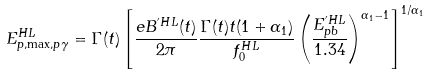Convert formula to latex. <formula><loc_0><loc_0><loc_500><loc_500>E ^ { H L } _ { p , \max , p \gamma } = \Gamma ( t ) \left [ \frac { e B ^ { ^ { \prime } H L } ( t ) } { 2 \pi } \frac { \Gamma ( t ) t ( 1 + \alpha _ { 1 } ) } { f ^ { H L } _ { 0 } } \left ( \frac { E ^ { ^ { \prime } H L } _ { p b } } { 1 . 3 4 } \right ) ^ { \alpha _ { 1 } - 1 } \right ] ^ { 1 / \alpha _ { 1 } }</formula> 